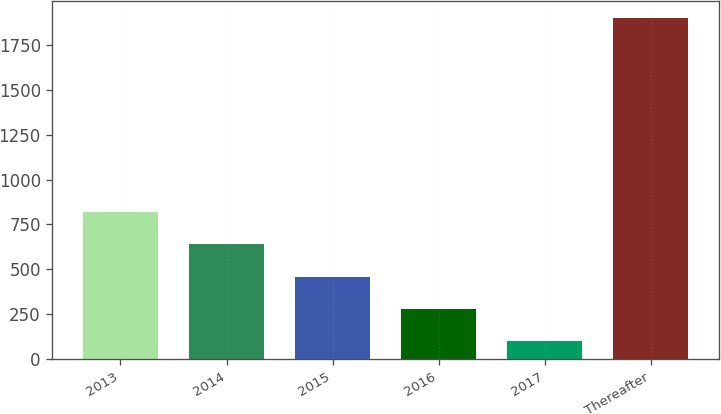Convert chart. <chart><loc_0><loc_0><loc_500><loc_500><bar_chart><fcel>2013<fcel>2014<fcel>2015<fcel>2016<fcel>2017<fcel>Thereafter<nl><fcel>819.54<fcel>638.98<fcel>458.42<fcel>277.86<fcel>97.3<fcel>1902.9<nl></chart> 